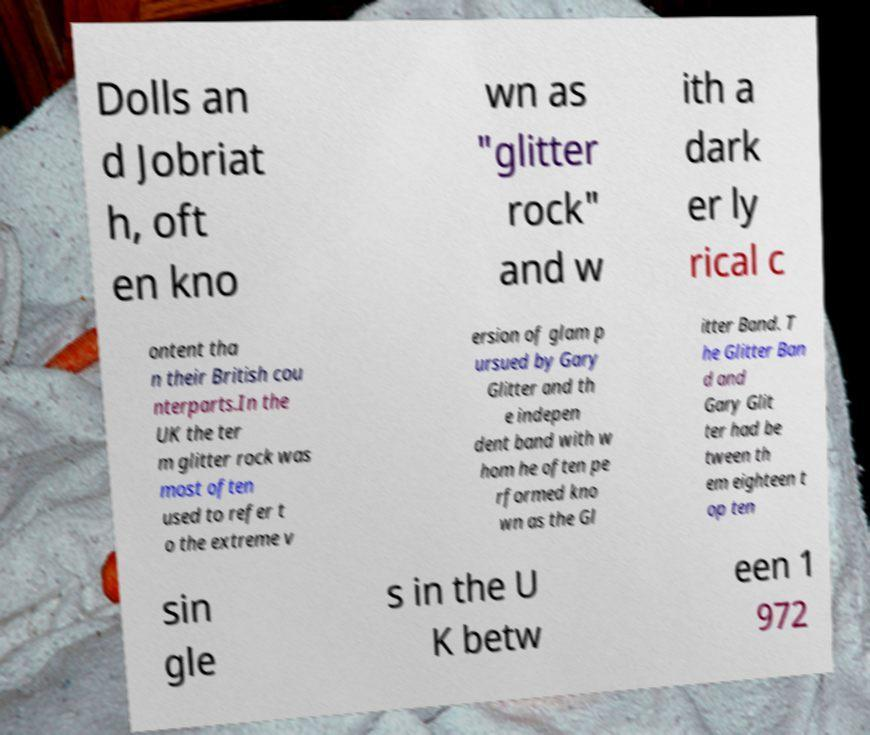I need the written content from this picture converted into text. Can you do that? Dolls an d Jobriat h, oft en kno wn as "glitter rock" and w ith a dark er ly rical c ontent tha n their British cou nterparts.In the UK the ter m glitter rock was most often used to refer t o the extreme v ersion of glam p ursued by Gary Glitter and th e indepen dent band with w hom he often pe rformed kno wn as the Gl itter Band. T he Glitter Ban d and Gary Glit ter had be tween th em eighteen t op ten sin gle s in the U K betw een 1 972 